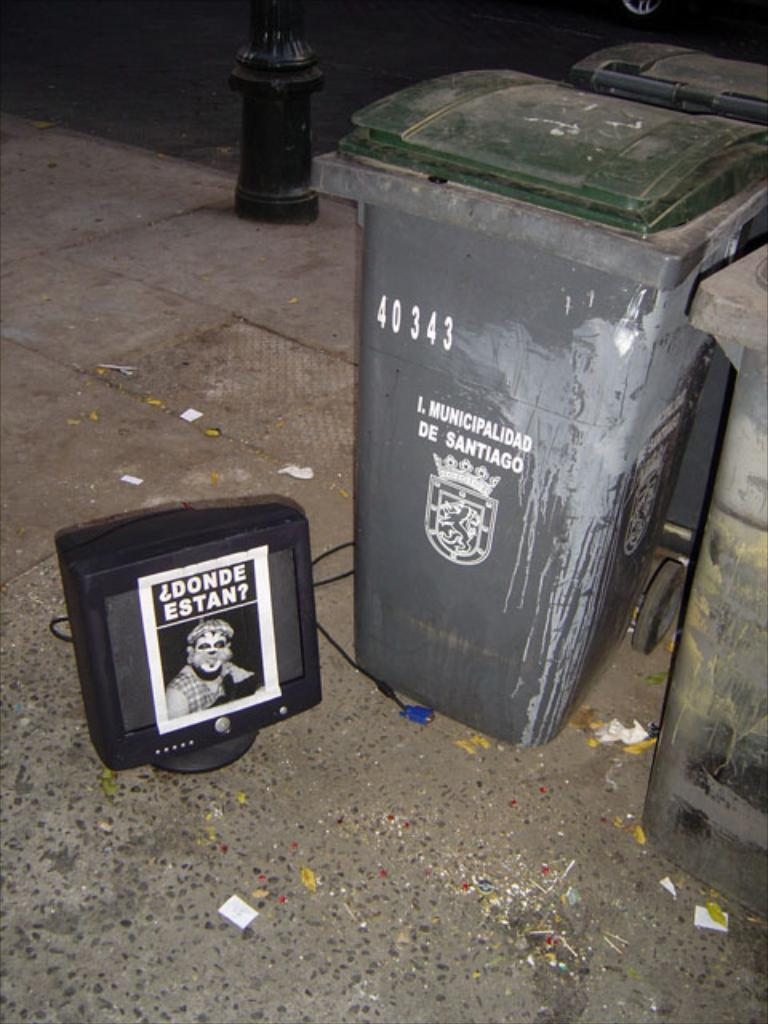<image>
Share a concise interpretation of the image provided. Monitor which has a label that says "Donde Estan" on it. 